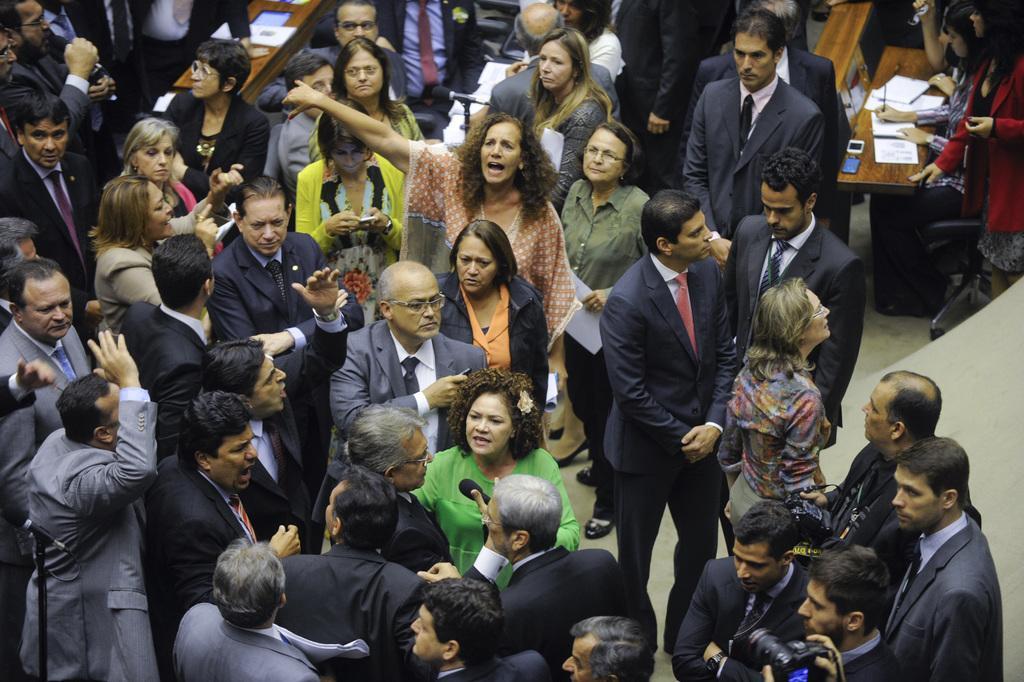In one or two sentences, can you explain what this image depicts? In this image there are people standing, in the background there are benches, on that benches there are papers near the benches there are people sitting on chairs. 